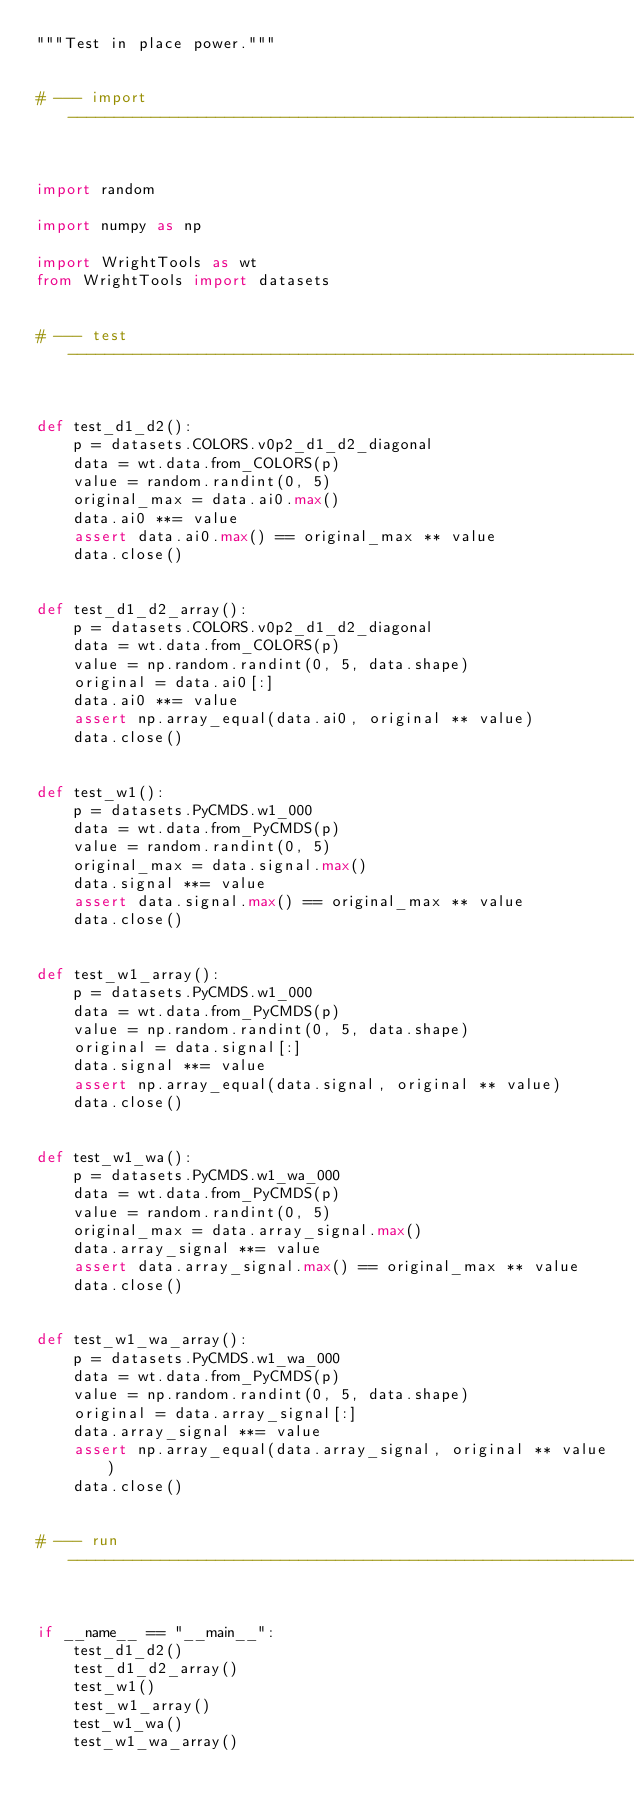<code> <loc_0><loc_0><loc_500><loc_500><_Python_>"""Test in place power."""


# --- import --------------------------------------------------------------------------------------


import random

import numpy as np

import WrightTools as wt
from WrightTools import datasets


# --- test ----------------------------------------------------------------------------------------


def test_d1_d2():
    p = datasets.COLORS.v0p2_d1_d2_diagonal
    data = wt.data.from_COLORS(p)
    value = random.randint(0, 5)
    original_max = data.ai0.max()
    data.ai0 **= value
    assert data.ai0.max() == original_max ** value
    data.close()


def test_d1_d2_array():
    p = datasets.COLORS.v0p2_d1_d2_diagonal
    data = wt.data.from_COLORS(p)
    value = np.random.randint(0, 5, data.shape)
    original = data.ai0[:]
    data.ai0 **= value
    assert np.array_equal(data.ai0, original ** value)
    data.close()


def test_w1():
    p = datasets.PyCMDS.w1_000
    data = wt.data.from_PyCMDS(p)
    value = random.randint(0, 5)
    original_max = data.signal.max()
    data.signal **= value
    assert data.signal.max() == original_max ** value
    data.close()


def test_w1_array():
    p = datasets.PyCMDS.w1_000
    data = wt.data.from_PyCMDS(p)
    value = np.random.randint(0, 5, data.shape)
    original = data.signal[:]
    data.signal **= value
    assert np.array_equal(data.signal, original ** value)
    data.close()


def test_w1_wa():
    p = datasets.PyCMDS.w1_wa_000
    data = wt.data.from_PyCMDS(p)
    value = random.randint(0, 5)
    original_max = data.array_signal.max()
    data.array_signal **= value
    assert data.array_signal.max() == original_max ** value
    data.close()


def test_w1_wa_array():
    p = datasets.PyCMDS.w1_wa_000
    data = wt.data.from_PyCMDS(p)
    value = np.random.randint(0, 5, data.shape)
    original = data.array_signal[:]
    data.array_signal **= value
    assert np.array_equal(data.array_signal, original ** value)
    data.close()


# --- run -----------------------------------------------------------------------------------------


if __name__ == "__main__":
    test_d1_d2()
    test_d1_d2_array()
    test_w1()
    test_w1_array()
    test_w1_wa()
    test_w1_wa_array()
</code> 